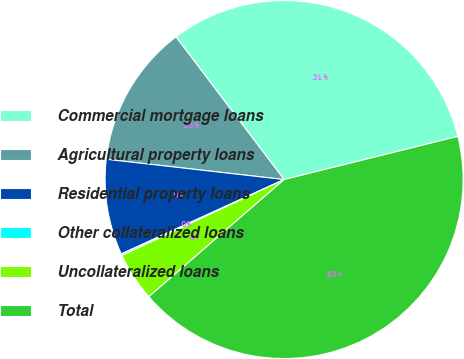Convert chart. <chart><loc_0><loc_0><loc_500><loc_500><pie_chart><fcel>Commercial mortgage loans<fcel>Agricultural property loans<fcel>Residential property loans<fcel>Other collateralized loans<fcel>Uncollateralized loans<fcel>Total<nl><fcel>31.45%<fcel>12.87%<fcel>8.63%<fcel>0.15%<fcel>4.39%<fcel>42.52%<nl></chart> 